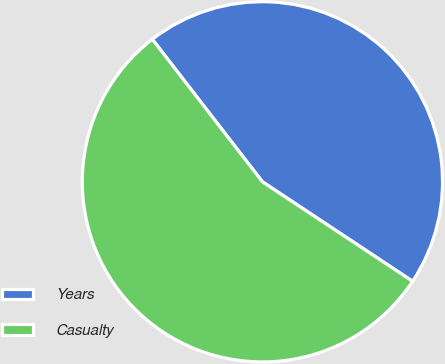Convert chart. <chart><loc_0><loc_0><loc_500><loc_500><pie_chart><fcel>Years<fcel>Casualty<nl><fcel>44.78%<fcel>55.22%<nl></chart> 